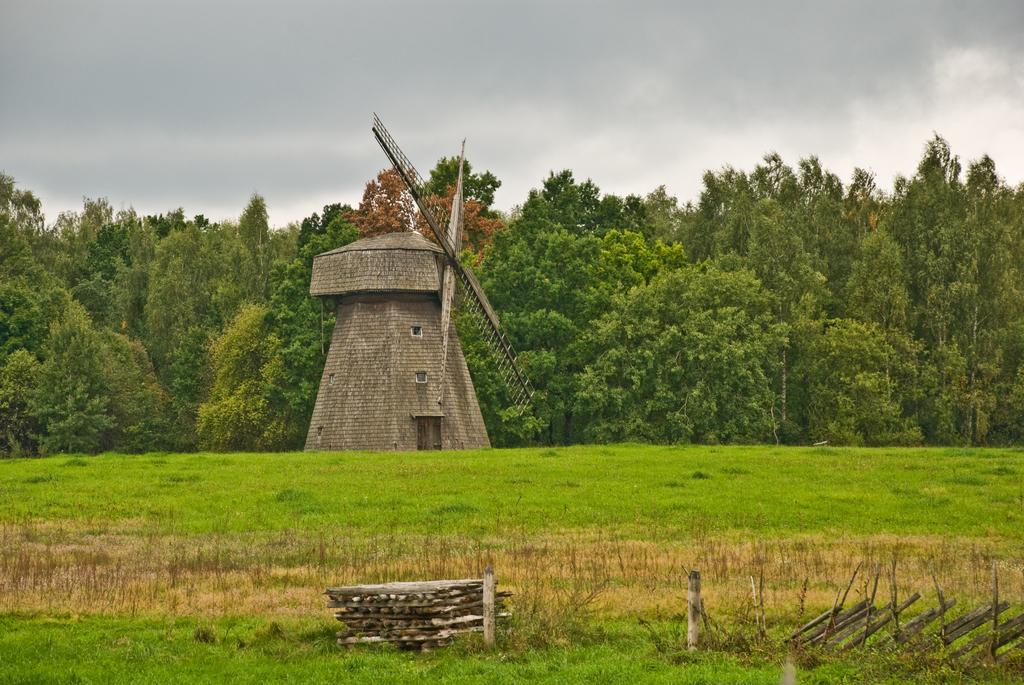What type of structure is in the image? There is a brown color brick windmill in the image. Where is the windmill located? The windmill is on the ground. What can be seen in the background of the image? There are trees visible in the background of the image. What type of vegetation is in the front bottom side of the image? There is grass in the front bottom side of the image. What else can be seen in the front bottom side of the image? There are bamboo sticks in the ground in the front bottom side of the image. What is the windmill's tendency to grant wishes in the image? There is no mention of wishes or the windmill granting wishes in the image. 